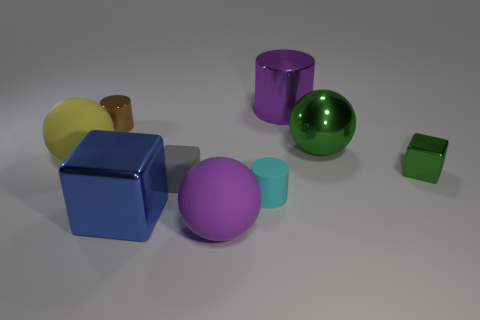Subtract all purple spheres. How many spheres are left? 2 Add 1 big blue matte spheres. How many objects exist? 10 Subtract all yellow spheres. How many spheres are left? 2 Subtract all spheres. How many objects are left? 6 Subtract 3 spheres. How many spheres are left? 0 Subtract all big cubes. Subtract all large green metallic balls. How many objects are left? 7 Add 9 large green balls. How many large green balls are left? 10 Add 5 cyan matte balls. How many cyan matte balls exist? 5 Subtract 0 red blocks. How many objects are left? 9 Subtract all yellow cylinders. Subtract all green balls. How many cylinders are left? 3 